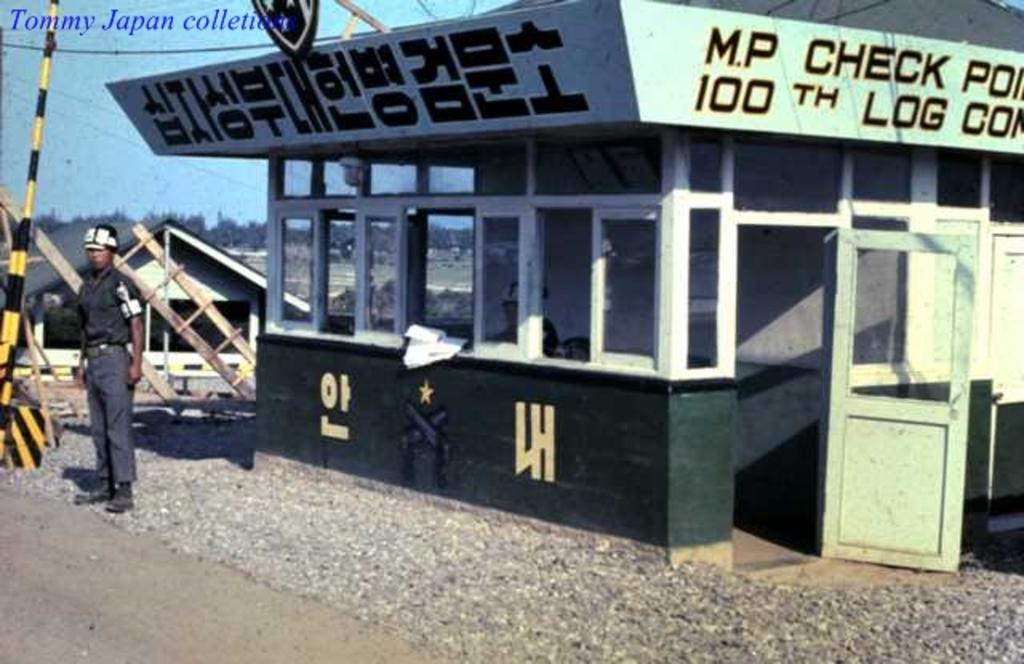What is the main subject of the image? There is a person standing in the image. Can you describe the person's attire? The person is wearing clothes, shoes, and a cap. What type of surface can be seen in the image? There are stones in the image. What kind of structure is present in the image? There is a glass room in the image. How many doors are visible in the image? There is one door in the image. What can be seen in the background of the image? There are trees in the image, and the sky is pale blue. Is there any additional mark or feature on the image? Yes, there is a watermark in the image. What type of lip can be seen on the person in the image? There is no lip visible on the person in the image, as they are wearing a cap. What color is the orange in the image? There is no orange present in the image. Is the person in the image part of an army? There is no indication in the image that the person is part of an army. 